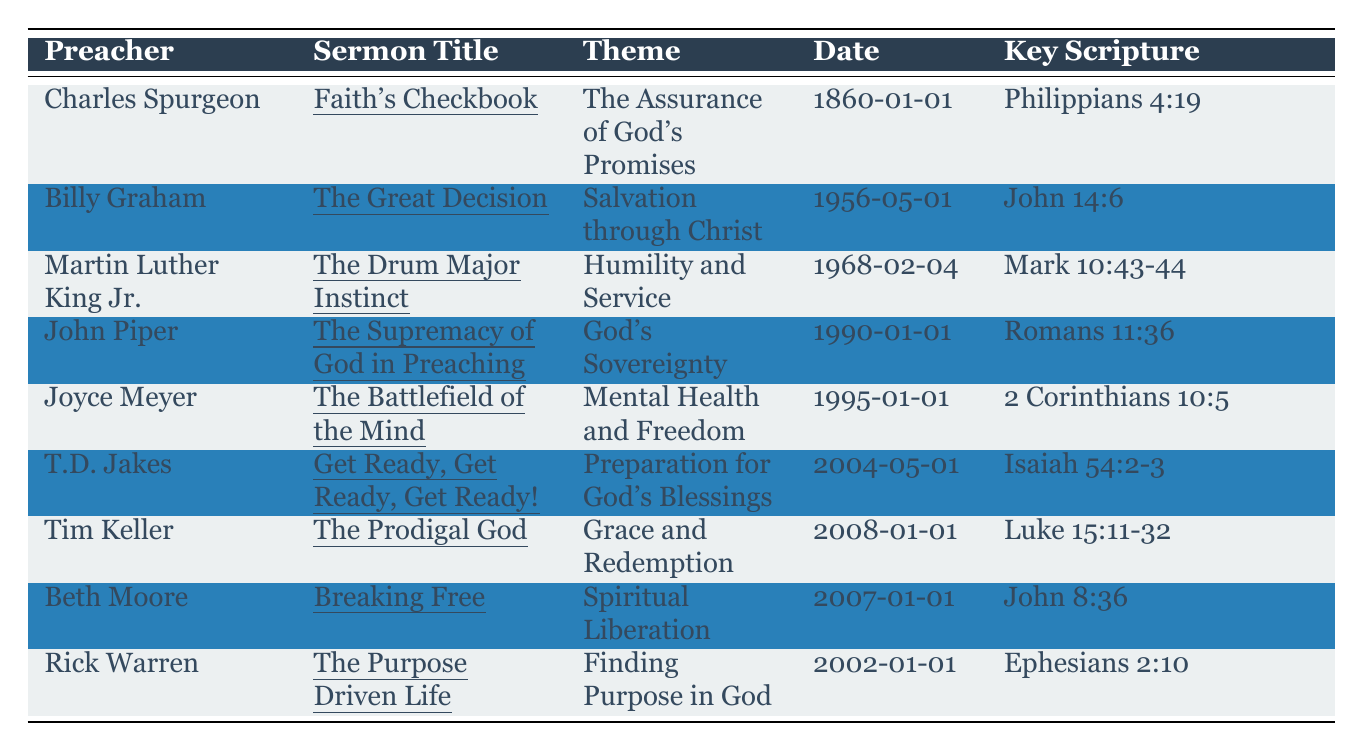What is the theme of Charles Spurgeon's sermon titled "Faith's Checkbook"? Referring to the table, under the preacher Charles Spurgeon and the sermon title "Faith's Checkbook," the theme listed is "The Assurance of God's Promises."
Answer: The Assurance of God's Promises Who preached the sermon titled "The Purpose Driven Life"? Looking up the sermon title "The Purpose Driven Life," the corresponding preacher in the table is Rick Warren.
Answer: Rick Warren What is the key scripture for Joyce Meyer's sermon? The table shows that Joyce Meyer's sermon "The Battlefield of the Mind" has the key scripture listed as "2 Corinthians 10:5."
Answer: 2 Corinthians 10:5 How many sermons were given after the year 2000? Reviewing the dates of the sermons listed, the sermons given after 2000 are "Get Ready, Get Ready, Get Ready!" (2004), "Breaking Free" (2007), and "The Prodigal God" (2008), totaling 3 sermons.
Answer: 3 Was "The Great Decision" sermon focused on themes related to mental health? The theme of "The Great Decision" sermon is "Salvation through Christ," which does not relate to mental health; therefore, the answer is no.
Answer: No Which sermon emphasizes humility and service? From the table, Martin Luther King Jr.'s sermon "The Drum Major Instinct" is noted under the theme of "Humility and Service."
Answer: The Drum Major Instinct What is the date of the sermon "Breaking Free"? The sermon "Breaking Free" by Beth Moore is dated "2007-01-01" according to the table.
Answer: 2007-01-01 Which preacher's sermon reflects on God's sovereignty? According to the table, John Piper's sermon "The Supremacy of God in Preaching" reflects on God's sovereignty.
Answer: John Piper What are the names of the preachers who focused on themes of grace and spiritual liberation? From the table, Tim Keller's sermon "The Prodigal God" focuses on grace, and Beth Moore's sermon "Breaking Free" focuses on spiritual liberation.
Answer: Tim Keller and Beth Moore How many different themes are represented in the sermons listed? The unique themes in the table are: The Assurance of God's Promises, Salvation through Christ, Humility and Service, God's Sovereignty, Mental Health and Freedom, Preparation for God's Blessings, Grace and Redemption, and Finding Purpose in God, totaling 8 different themes.
Answer: 8 Can you list the key scriptures for the sermons related to blessings and redemption? For T.D. Jakes's sermon "Get Ready, Get Ready, Get Ready!" the key scripture is "Isaiah 54:2-3," and for Tim Keller's sermon "The Prodigal God," the key scripture is "Luke 15:11-32." Therefore, the key scriptures are Isaiah 54:2-3 and Luke 15:11-32.
Answer: Isaiah 54:2-3 and Luke 15:11-32 